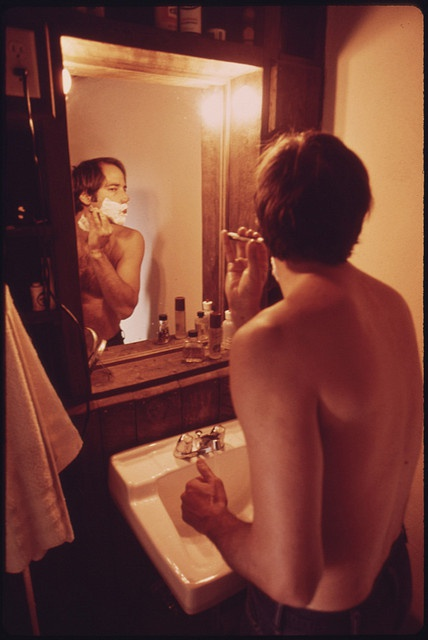Describe the objects in this image and their specific colors. I can see people in black, maroon, and brown tones and sink in black, tan, red, maroon, and brown tones in this image. 